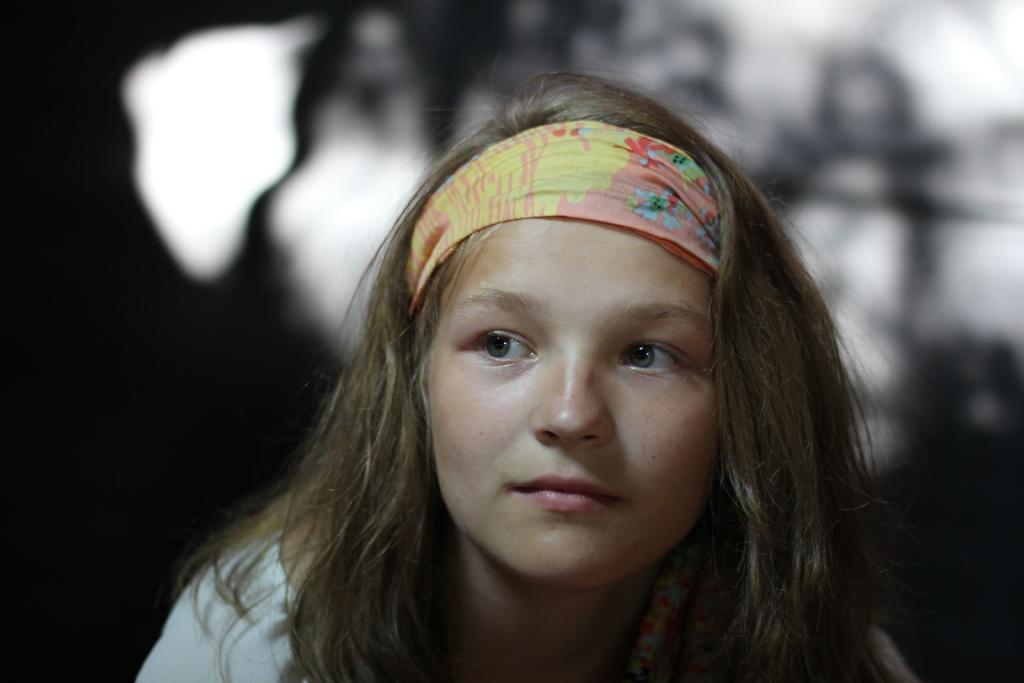Describe this image in one or two sentences. In the image we can see there is a girl wearing hairband. Behind the image is blur. 